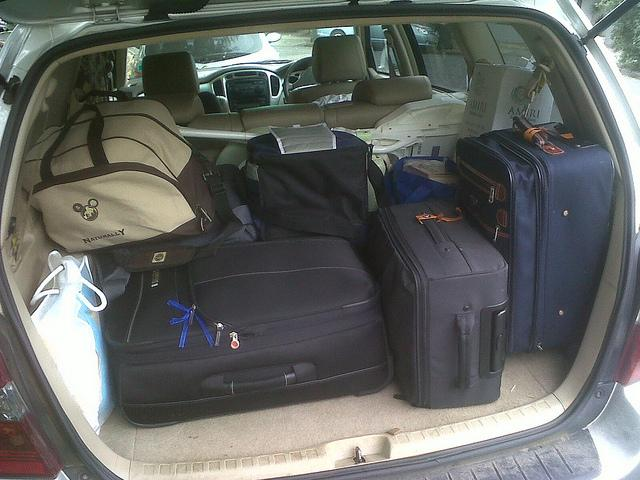Why would this person load the back of their car with these? traveling 